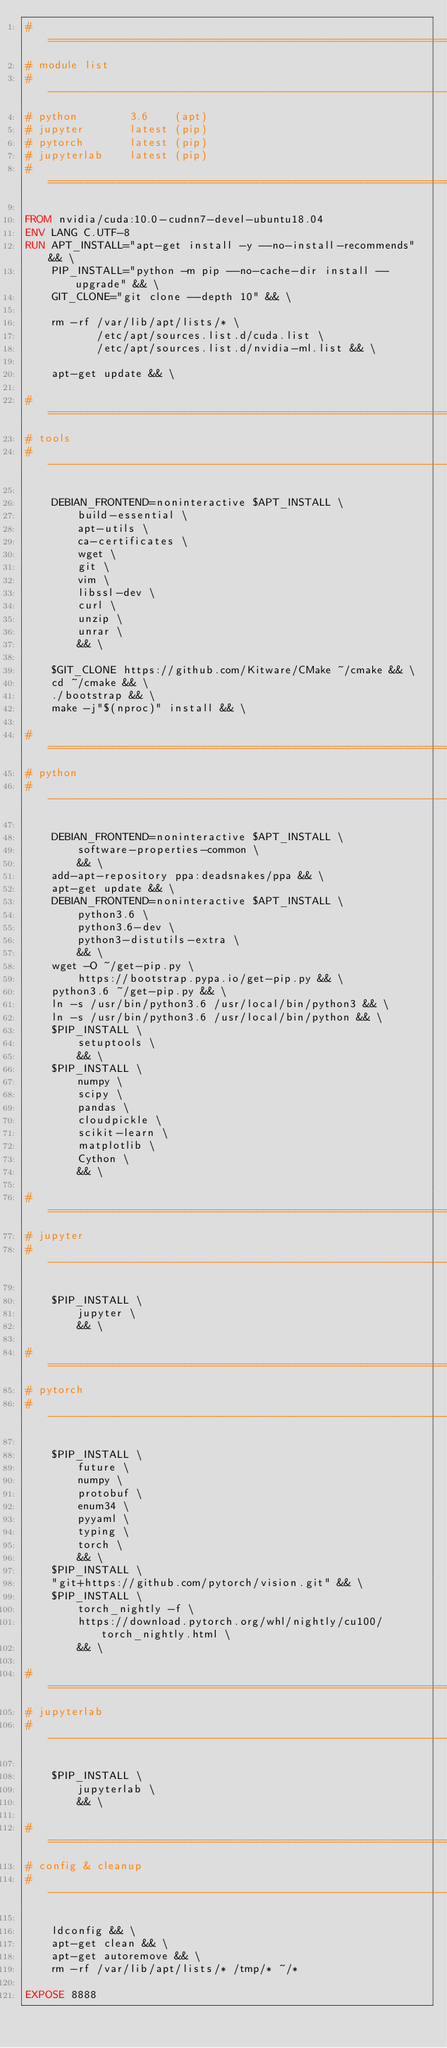<code> <loc_0><loc_0><loc_500><loc_500><_Dockerfile_># ==================================================================
# module list
# ------------------------------------------------------------------
# python        3.6    (apt)
# jupyter       latest (pip)
# pytorch       latest (pip)
# jupyterlab    latest (pip)
# ==================================================================

FROM nvidia/cuda:10.0-cudnn7-devel-ubuntu18.04
ENV LANG C.UTF-8
RUN APT_INSTALL="apt-get install -y --no-install-recommends" && \
    PIP_INSTALL="python -m pip --no-cache-dir install --upgrade" && \
    GIT_CLONE="git clone --depth 10" && \

    rm -rf /var/lib/apt/lists/* \
           /etc/apt/sources.list.d/cuda.list \
           /etc/apt/sources.list.d/nvidia-ml.list && \

    apt-get update && \

# ==================================================================
# tools
# ------------------------------------------------------------------

    DEBIAN_FRONTEND=noninteractive $APT_INSTALL \
        build-essential \
        apt-utils \
        ca-certificates \
        wget \
        git \
        vim \
        libssl-dev \
        curl \
        unzip \
        unrar \
        && \

    $GIT_CLONE https://github.com/Kitware/CMake ~/cmake && \
    cd ~/cmake && \
    ./bootstrap && \
    make -j"$(nproc)" install && \

# ==================================================================
# python
# ------------------------------------------------------------------

    DEBIAN_FRONTEND=noninteractive $APT_INSTALL \
        software-properties-common \
        && \
    add-apt-repository ppa:deadsnakes/ppa && \
    apt-get update && \
    DEBIAN_FRONTEND=noninteractive $APT_INSTALL \
        python3.6 \
        python3.6-dev \
        python3-distutils-extra \
        && \
    wget -O ~/get-pip.py \
        https://bootstrap.pypa.io/get-pip.py && \
    python3.6 ~/get-pip.py && \
    ln -s /usr/bin/python3.6 /usr/local/bin/python3 && \
    ln -s /usr/bin/python3.6 /usr/local/bin/python && \
    $PIP_INSTALL \
        setuptools \
        && \
    $PIP_INSTALL \
        numpy \
        scipy \
        pandas \
        cloudpickle \
        scikit-learn \
        matplotlib \
        Cython \
        && \

# ==================================================================
# jupyter
# ------------------------------------------------------------------

    $PIP_INSTALL \
        jupyter \
        && \

# ==================================================================
# pytorch
# ------------------------------------------------------------------

    $PIP_INSTALL \
        future \
        numpy \
        protobuf \
        enum34 \
        pyyaml \
        typing \
    	torch \
        && \
    $PIP_INSTALL \
    "git+https://github.com/pytorch/vision.git" && \
    $PIP_INSTALL \
        torch_nightly -f \
        https://download.pytorch.org/whl/nightly/cu100/torch_nightly.html \
        && \

# ==================================================================
# jupyterlab
# ------------------------------------------------------------------

    $PIP_INSTALL \
        jupyterlab \
        && \

# ==================================================================
# config & cleanup
# ------------------------------------------------------------------

    ldconfig && \
    apt-get clean && \
    apt-get autoremove && \
    rm -rf /var/lib/apt/lists/* /tmp/* ~/*

EXPOSE 8888
</code> 